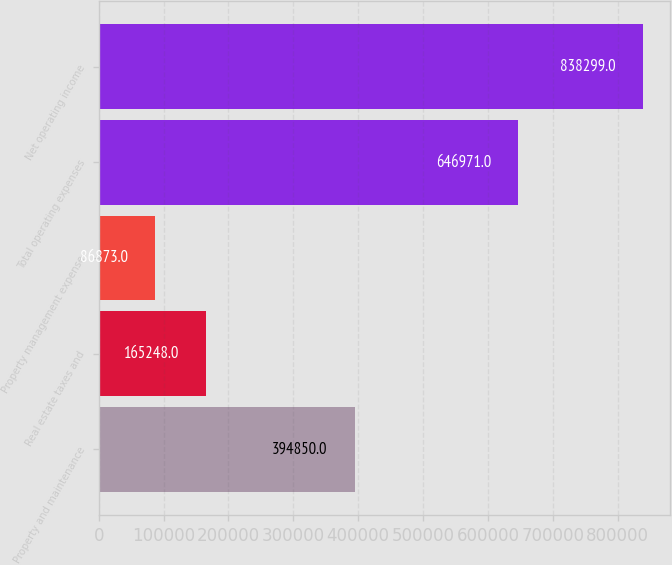Convert chart. <chart><loc_0><loc_0><loc_500><loc_500><bar_chart><fcel>Property and maintenance<fcel>Real estate taxes and<fcel>Property management expense<fcel>Total operating expenses<fcel>Net operating income<nl><fcel>394850<fcel>165248<fcel>86873<fcel>646971<fcel>838299<nl></chart> 